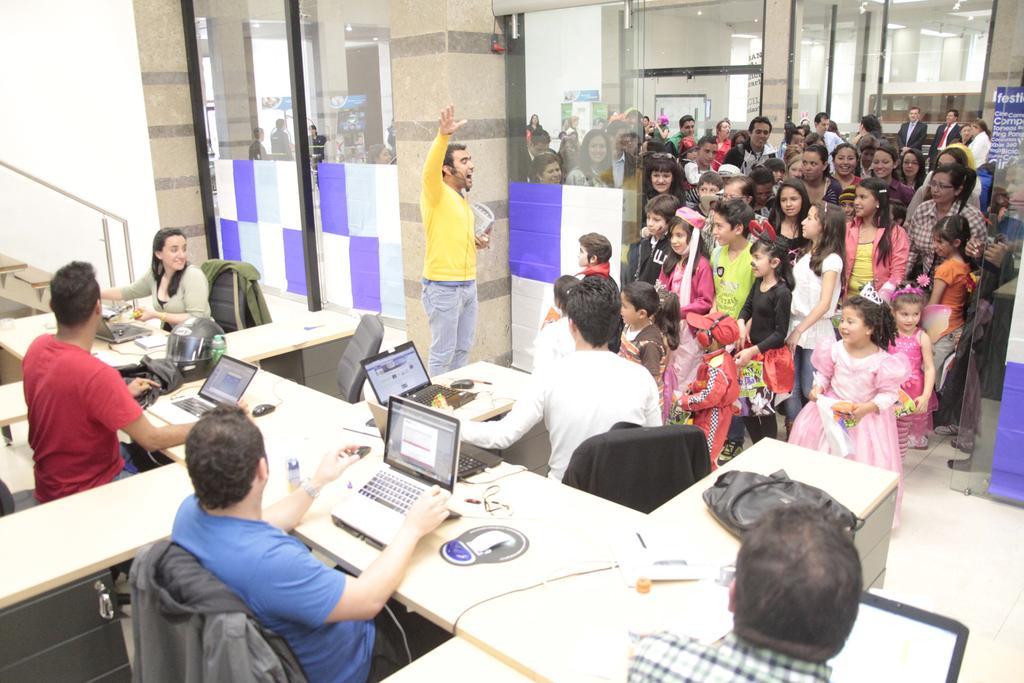In one or two sentences, can you explain what this image depicts? In this image i can see three men sitting and a woman sitting on a chair there is a laptop in front of them, at the back ground i can see a man standing , and a group of people standing and a glass door. 